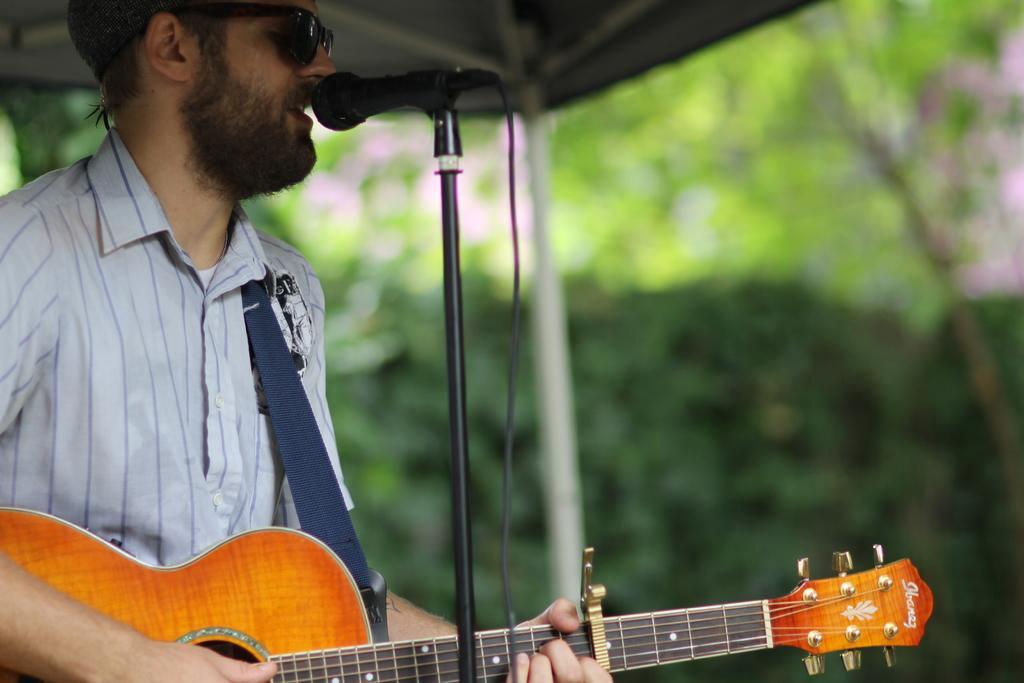Please provide a concise description of this image. This picture shows a man standing and playing a guitar and singing with the help of a microphone and we see few trees around. 